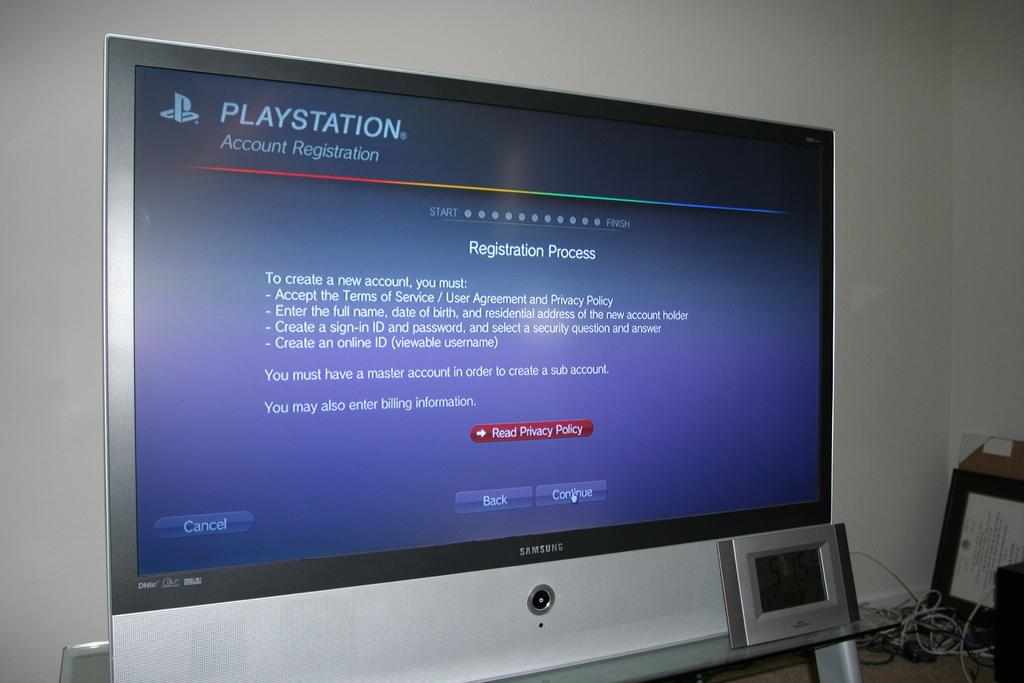Provide a one-sentence caption for the provided image. A very large screen with blue background with Playstation registration process on it. 